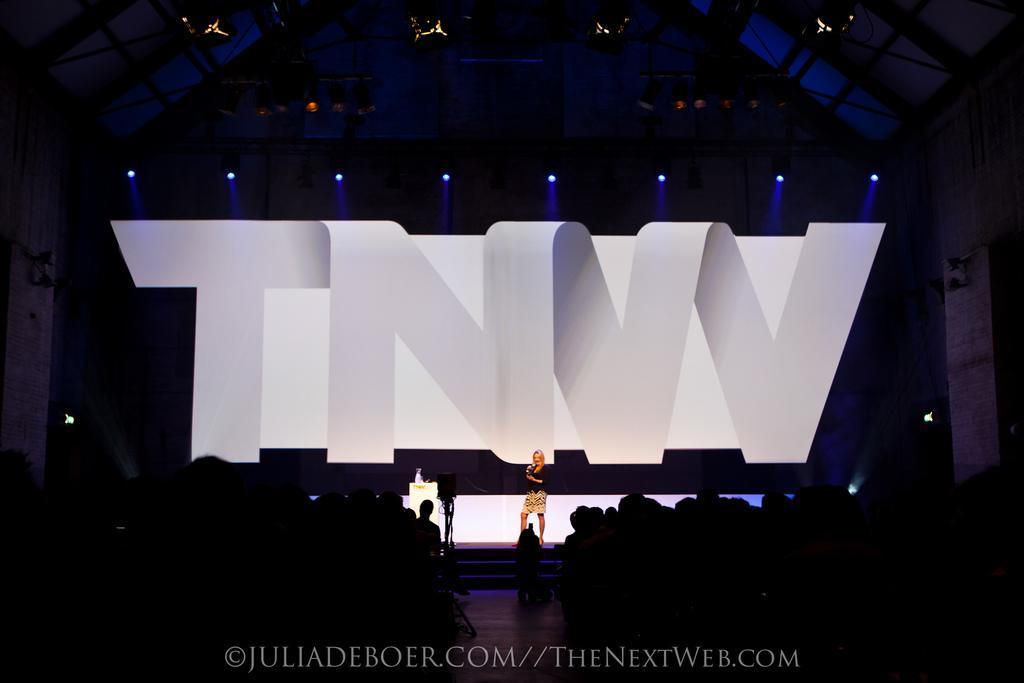In one or two sentences, can you explain what this image depicts? This part of the image is dark where we can see these people are sitting on the chair and this person is standing on the stage and we can see a podium here. In the background, we can see the show lights and here we can see some text. Here we can see the watermark on the bottom of the image. 